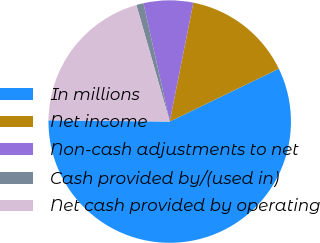Convert chart to OTSL. <chart><loc_0><loc_0><loc_500><loc_500><pie_chart><fcel>In millions<fcel>Net income<fcel>Non-cash adjustments to net<fcel>Cash provided by/(used in)<fcel>Net cash provided by operating<nl><fcel>57.35%<fcel>14.7%<fcel>6.6%<fcel>0.96%<fcel>20.4%<nl></chart> 